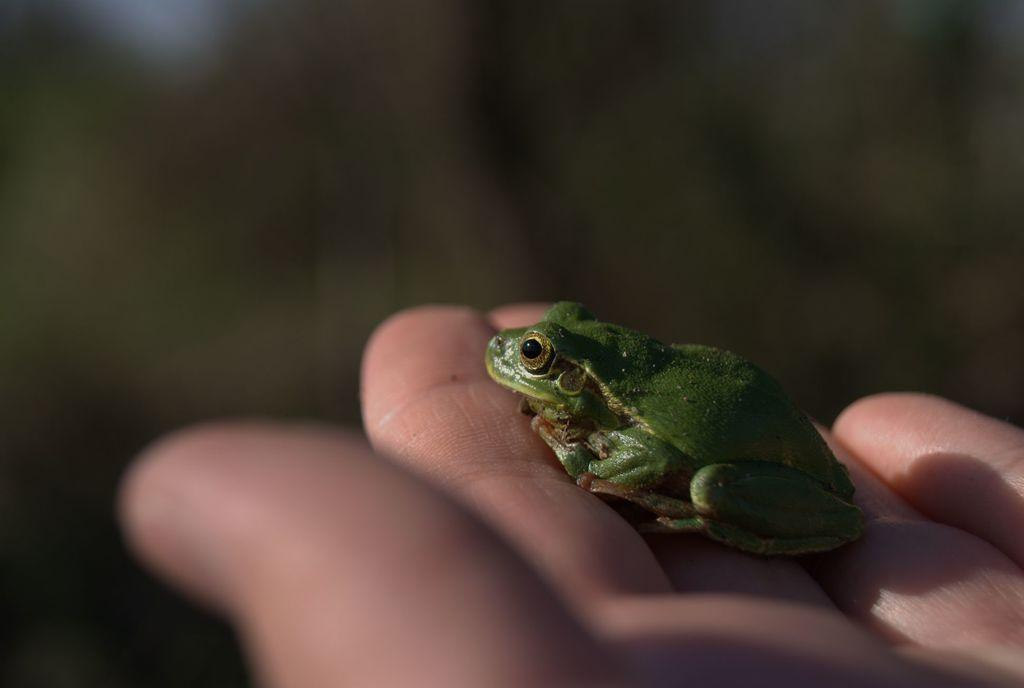What is the main subject of the image? The main subject of the image is a frog. Where is the frog located in the image? The frog is on a person's fingers. Can you describe the background of the image? The background of the image is blurred. What type of church can be seen in the background of the image? There is no church present in the image; the background is blurred. What flavor of car can be seen in the image? There is no car present in the image, and therefore no flavor can be associated with it. 